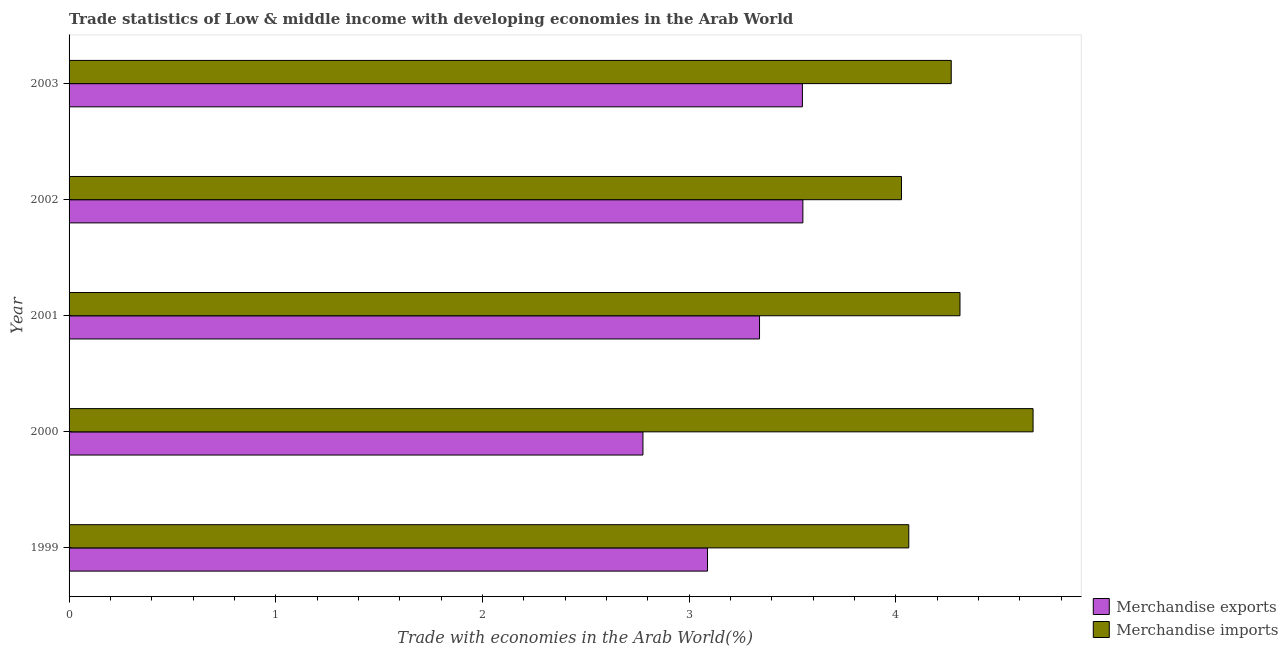How many different coloured bars are there?
Offer a very short reply. 2. How many groups of bars are there?
Keep it short and to the point. 5. How many bars are there on the 4th tick from the top?
Provide a short and direct response. 2. How many bars are there on the 3rd tick from the bottom?
Offer a terse response. 2. In how many cases, is the number of bars for a given year not equal to the number of legend labels?
Make the answer very short. 0. What is the merchandise imports in 2003?
Provide a short and direct response. 4.27. Across all years, what is the maximum merchandise imports?
Provide a succinct answer. 4.66. Across all years, what is the minimum merchandise imports?
Your answer should be compact. 4.03. What is the total merchandise exports in the graph?
Offer a very short reply. 16.3. What is the difference between the merchandise imports in 2000 and that in 2002?
Provide a short and direct response. 0.64. What is the difference between the merchandise exports in 1999 and the merchandise imports in 2003?
Give a very brief answer. -1.18. What is the average merchandise exports per year?
Offer a terse response. 3.26. In the year 2003, what is the difference between the merchandise imports and merchandise exports?
Make the answer very short. 0.72. What is the ratio of the merchandise exports in 2000 to that in 2003?
Offer a very short reply. 0.78. What is the difference between the highest and the second highest merchandise exports?
Provide a short and direct response. 0. What is the difference between the highest and the lowest merchandise imports?
Give a very brief answer. 0.64. What does the 1st bar from the top in 2000 represents?
Give a very brief answer. Merchandise imports. Are all the bars in the graph horizontal?
Your answer should be compact. Yes. How many years are there in the graph?
Ensure brevity in your answer.  5. What is the difference between two consecutive major ticks on the X-axis?
Your answer should be very brief. 1. Are the values on the major ticks of X-axis written in scientific E-notation?
Ensure brevity in your answer.  No. Does the graph contain grids?
Keep it short and to the point. No. How are the legend labels stacked?
Offer a terse response. Vertical. What is the title of the graph?
Keep it short and to the point. Trade statistics of Low & middle income with developing economies in the Arab World. What is the label or title of the X-axis?
Keep it short and to the point. Trade with economies in the Arab World(%). What is the Trade with economies in the Arab World(%) in Merchandise exports in 1999?
Your response must be concise. 3.09. What is the Trade with economies in the Arab World(%) of Merchandise imports in 1999?
Your answer should be compact. 4.06. What is the Trade with economies in the Arab World(%) of Merchandise exports in 2000?
Offer a very short reply. 2.78. What is the Trade with economies in the Arab World(%) in Merchandise imports in 2000?
Your response must be concise. 4.66. What is the Trade with economies in the Arab World(%) in Merchandise exports in 2001?
Your response must be concise. 3.34. What is the Trade with economies in the Arab World(%) of Merchandise imports in 2001?
Offer a terse response. 4.31. What is the Trade with economies in the Arab World(%) in Merchandise exports in 2002?
Give a very brief answer. 3.55. What is the Trade with economies in the Arab World(%) of Merchandise imports in 2002?
Your answer should be very brief. 4.03. What is the Trade with economies in the Arab World(%) in Merchandise exports in 2003?
Keep it short and to the point. 3.55. What is the Trade with economies in the Arab World(%) in Merchandise imports in 2003?
Make the answer very short. 4.27. Across all years, what is the maximum Trade with economies in the Arab World(%) in Merchandise exports?
Give a very brief answer. 3.55. Across all years, what is the maximum Trade with economies in the Arab World(%) in Merchandise imports?
Provide a succinct answer. 4.66. Across all years, what is the minimum Trade with economies in the Arab World(%) in Merchandise exports?
Offer a very short reply. 2.78. Across all years, what is the minimum Trade with economies in the Arab World(%) in Merchandise imports?
Give a very brief answer. 4.03. What is the total Trade with economies in the Arab World(%) in Merchandise exports in the graph?
Keep it short and to the point. 16.3. What is the total Trade with economies in the Arab World(%) of Merchandise imports in the graph?
Give a very brief answer. 21.33. What is the difference between the Trade with economies in the Arab World(%) of Merchandise exports in 1999 and that in 2000?
Provide a succinct answer. 0.31. What is the difference between the Trade with economies in the Arab World(%) in Merchandise imports in 1999 and that in 2000?
Your response must be concise. -0.6. What is the difference between the Trade with economies in the Arab World(%) in Merchandise exports in 1999 and that in 2001?
Provide a short and direct response. -0.25. What is the difference between the Trade with economies in the Arab World(%) in Merchandise imports in 1999 and that in 2001?
Make the answer very short. -0.25. What is the difference between the Trade with economies in the Arab World(%) in Merchandise exports in 1999 and that in 2002?
Offer a terse response. -0.46. What is the difference between the Trade with economies in the Arab World(%) in Merchandise imports in 1999 and that in 2002?
Your answer should be compact. 0.04. What is the difference between the Trade with economies in the Arab World(%) of Merchandise exports in 1999 and that in 2003?
Your response must be concise. -0.46. What is the difference between the Trade with economies in the Arab World(%) in Merchandise imports in 1999 and that in 2003?
Provide a short and direct response. -0.21. What is the difference between the Trade with economies in the Arab World(%) of Merchandise exports in 2000 and that in 2001?
Provide a succinct answer. -0.56. What is the difference between the Trade with economies in the Arab World(%) of Merchandise imports in 2000 and that in 2001?
Offer a very short reply. 0.35. What is the difference between the Trade with economies in the Arab World(%) of Merchandise exports in 2000 and that in 2002?
Make the answer very short. -0.77. What is the difference between the Trade with economies in the Arab World(%) of Merchandise imports in 2000 and that in 2002?
Your answer should be very brief. 0.64. What is the difference between the Trade with economies in the Arab World(%) in Merchandise exports in 2000 and that in 2003?
Give a very brief answer. -0.77. What is the difference between the Trade with economies in the Arab World(%) of Merchandise imports in 2000 and that in 2003?
Make the answer very short. 0.4. What is the difference between the Trade with economies in the Arab World(%) of Merchandise exports in 2001 and that in 2002?
Give a very brief answer. -0.21. What is the difference between the Trade with economies in the Arab World(%) of Merchandise imports in 2001 and that in 2002?
Your answer should be very brief. 0.28. What is the difference between the Trade with economies in the Arab World(%) in Merchandise exports in 2001 and that in 2003?
Your response must be concise. -0.21. What is the difference between the Trade with economies in the Arab World(%) in Merchandise imports in 2001 and that in 2003?
Offer a terse response. 0.04. What is the difference between the Trade with economies in the Arab World(%) of Merchandise exports in 2002 and that in 2003?
Your response must be concise. 0. What is the difference between the Trade with economies in the Arab World(%) of Merchandise imports in 2002 and that in 2003?
Offer a very short reply. -0.24. What is the difference between the Trade with economies in the Arab World(%) in Merchandise exports in 1999 and the Trade with economies in the Arab World(%) in Merchandise imports in 2000?
Your answer should be very brief. -1.58. What is the difference between the Trade with economies in the Arab World(%) in Merchandise exports in 1999 and the Trade with economies in the Arab World(%) in Merchandise imports in 2001?
Your answer should be compact. -1.22. What is the difference between the Trade with economies in the Arab World(%) in Merchandise exports in 1999 and the Trade with economies in the Arab World(%) in Merchandise imports in 2002?
Keep it short and to the point. -0.94. What is the difference between the Trade with economies in the Arab World(%) of Merchandise exports in 1999 and the Trade with economies in the Arab World(%) of Merchandise imports in 2003?
Ensure brevity in your answer.  -1.18. What is the difference between the Trade with economies in the Arab World(%) of Merchandise exports in 2000 and the Trade with economies in the Arab World(%) of Merchandise imports in 2001?
Ensure brevity in your answer.  -1.53. What is the difference between the Trade with economies in the Arab World(%) in Merchandise exports in 2000 and the Trade with economies in the Arab World(%) in Merchandise imports in 2002?
Give a very brief answer. -1.25. What is the difference between the Trade with economies in the Arab World(%) in Merchandise exports in 2000 and the Trade with economies in the Arab World(%) in Merchandise imports in 2003?
Provide a short and direct response. -1.49. What is the difference between the Trade with economies in the Arab World(%) of Merchandise exports in 2001 and the Trade with economies in the Arab World(%) of Merchandise imports in 2002?
Your response must be concise. -0.69. What is the difference between the Trade with economies in the Arab World(%) of Merchandise exports in 2001 and the Trade with economies in the Arab World(%) of Merchandise imports in 2003?
Provide a short and direct response. -0.93. What is the difference between the Trade with economies in the Arab World(%) in Merchandise exports in 2002 and the Trade with economies in the Arab World(%) in Merchandise imports in 2003?
Your response must be concise. -0.72. What is the average Trade with economies in the Arab World(%) of Merchandise exports per year?
Your answer should be compact. 3.26. What is the average Trade with economies in the Arab World(%) in Merchandise imports per year?
Ensure brevity in your answer.  4.27. In the year 1999, what is the difference between the Trade with economies in the Arab World(%) of Merchandise exports and Trade with economies in the Arab World(%) of Merchandise imports?
Offer a very short reply. -0.97. In the year 2000, what is the difference between the Trade with economies in the Arab World(%) in Merchandise exports and Trade with economies in the Arab World(%) in Merchandise imports?
Ensure brevity in your answer.  -1.89. In the year 2001, what is the difference between the Trade with economies in the Arab World(%) in Merchandise exports and Trade with economies in the Arab World(%) in Merchandise imports?
Give a very brief answer. -0.97. In the year 2002, what is the difference between the Trade with economies in the Arab World(%) in Merchandise exports and Trade with economies in the Arab World(%) in Merchandise imports?
Your answer should be compact. -0.48. In the year 2003, what is the difference between the Trade with economies in the Arab World(%) of Merchandise exports and Trade with economies in the Arab World(%) of Merchandise imports?
Provide a short and direct response. -0.72. What is the ratio of the Trade with economies in the Arab World(%) in Merchandise exports in 1999 to that in 2000?
Ensure brevity in your answer.  1.11. What is the ratio of the Trade with economies in the Arab World(%) of Merchandise imports in 1999 to that in 2000?
Provide a succinct answer. 0.87. What is the ratio of the Trade with economies in the Arab World(%) in Merchandise exports in 1999 to that in 2001?
Provide a succinct answer. 0.92. What is the ratio of the Trade with economies in the Arab World(%) in Merchandise imports in 1999 to that in 2001?
Offer a terse response. 0.94. What is the ratio of the Trade with economies in the Arab World(%) of Merchandise exports in 1999 to that in 2002?
Provide a succinct answer. 0.87. What is the ratio of the Trade with economies in the Arab World(%) in Merchandise imports in 1999 to that in 2002?
Provide a short and direct response. 1.01. What is the ratio of the Trade with economies in the Arab World(%) of Merchandise exports in 1999 to that in 2003?
Give a very brief answer. 0.87. What is the ratio of the Trade with economies in the Arab World(%) of Merchandise imports in 1999 to that in 2003?
Provide a short and direct response. 0.95. What is the ratio of the Trade with economies in the Arab World(%) of Merchandise exports in 2000 to that in 2001?
Your answer should be very brief. 0.83. What is the ratio of the Trade with economies in the Arab World(%) in Merchandise imports in 2000 to that in 2001?
Make the answer very short. 1.08. What is the ratio of the Trade with economies in the Arab World(%) of Merchandise exports in 2000 to that in 2002?
Offer a very short reply. 0.78. What is the ratio of the Trade with economies in the Arab World(%) of Merchandise imports in 2000 to that in 2002?
Offer a terse response. 1.16. What is the ratio of the Trade with economies in the Arab World(%) of Merchandise exports in 2000 to that in 2003?
Your response must be concise. 0.78. What is the ratio of the Trade with economies in the Arab World(%) of Merchandise imports in 2000 to that in 2003?
Provide a succinct answer. 1.09. What is the ratio of the Trade with economies in the Arab World(%) in Merchandise exports in 2001 to that in 2002?
Offer a terse response. 0.94. What is the ratio of the Trade with economies in the Arab World(%) of Merchandise imports in 2001 to that in 2002?
Offer a very short reply. 1.07. What is the ratio of the Trade with economies in the Arab World(%) in Merchandise exports in 2001 to that in 2003?
Offer a terse response. 0.94. What is the ratio of the Trade with economies in the Arab World(%) of Merchandise imports in 2001 to that in 2003?
Your response must be concise. 1.01. What is the ratio of the Trade with economies in the Arab World(%) of Merchandise exports in 2002 to that in 2003?
Provide a succinct answer. 1. What is the ratio of the Trade with economies in the Arab World(%) of Merchandise imports in 2002 to that in 2003?
Offer a terse response. 0.94. What is the difference between the highest and the second highest Trade with economies in the Arab World(%) of Merchandise exports?
Offer a terse response. 0. What is the difference between the highest and the second highest Trade with economies in the Arab World(%) in Merchandise imports?
Your answer should be compact. 0.35. What is the difference between the highest and the lowest Trade with economies in the Arab World(%) in Merchandise exports?
Offer a very short reply. 0.77. What is the difference between the highest and the lowest Trade with economies in the Arab World(%) in Merchandise imports?
Your answer should be compact. 0.64. 